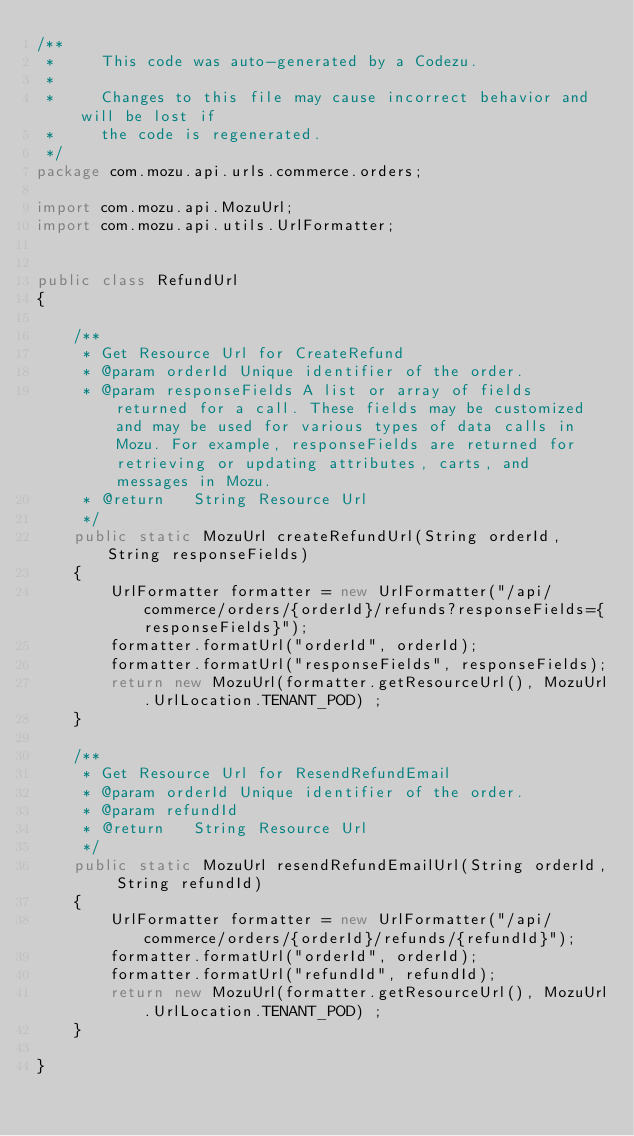<code> <loc_0><loc_0><loc_500><loc_500><_Java_>/**
 *     This code was auto-generated by a Codezu.     
 *
 *     Changes to this file may cause incorrect behavior and will be lost if
 *     the code is regenerated.
 */
package com.mozu.api.urls.commerce.orders;

import com.mozu.api.MozuUrl;
import com.mozu.api.utils.UrlFormatter;


public class RefundUrl
{

	/**
	 * Get Resource Url for CreateRefund
	 * @param orderId Unique identifier of the order.
	 * @param responseFields A list or array of fields returned for a call. These fields may be customized and may be used for various types of data calls in Mozu. For example, responseFields are returned for retrieving or updating attributes, carts, and messages in Mozu.
	 * @return   String Resource Url
	 */
	public static MozuUrl createRefundUrl(String orderId, String responseFields)
	{
		UrlFormatter formatter = new UrlFormatter("/api/commerce/orders/{orderId}/refunds?responseFields={responseFields}");
		formatter.formatUrl("orderId", orderId);
		formatter.formatUrl("responseFields", responseFields);
		return new MozuUrl(formatter.getResourceUrl(), MozuUrl.UrlLocation.TENANT_POD) ;
	}

	/**
	 * Get Resource Url for ResendRefundEmail
	 * @param orderId Unique identifier of the order.
	 * @param refundId 
	 * @return   String Resource Url
	 */
	public static MozuUrl resendRefundEmailUrl(String orderId, String refundId)
	{
		UrlFormatter formatter = new UrlFormatter("/api/commerce/orders/{orderId}/refunds/{refundId}");
		formatter.formatUrl("orderId", orderId);
		formatter.formatUrl("refundId", refundId);
		return new MozuUrl(formatter.getResourceUrl(), MozuUrl.UrlLocation.TENANT_POD) ;
	}

}

</code> 